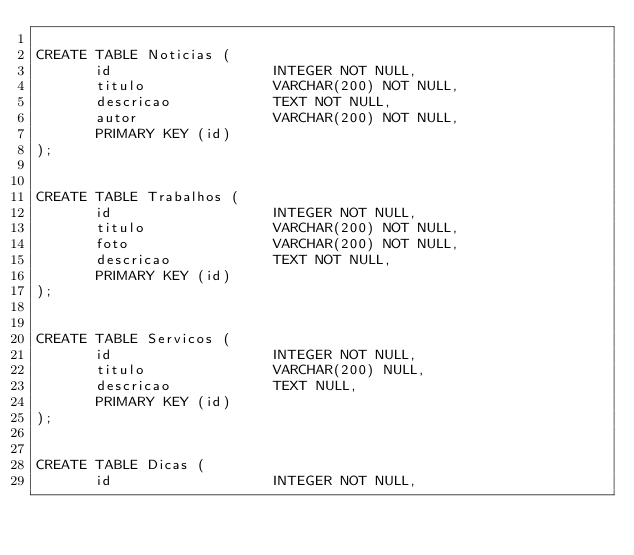Convert code to text. <code><loc_0><loc_0><loc_500><loc_500><_SQL_>
CREATE TABLE Noticias (
       id                   INTEGER NOT NULL,
       titulo               VARCHAR(200) NOT NULL,
       descricao            TEXT NOT NULL,
       autor                VARCHAR(200) NOT NULL,
       PRIMARY KEY (id)
);


CREATE TABLE Trabalhos (
       id                   INTEGER NOT NULL,
       titulo               VARCHAR(200) NOT NULL,
       foto                 VARCHAR(200) NOT NULL,
       descricao            TEXT NOT NULL,
       PRIMARY KEY (id)
);


CREATE TABLE Servicos (
       id                   INTEGER NOT NULL,
       titulo               VARCHAR(200) NULL,
       descricao            TEXT NULL,
       PRIMARY KEY (id)
);


CREATE TABLE Dicas (
       id                   INTEGER NOT NULL,</code> 